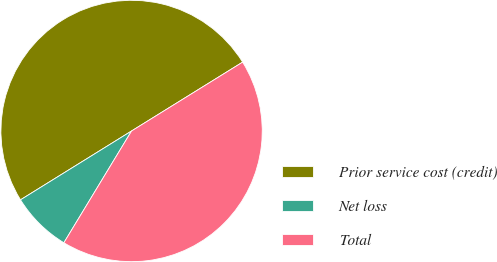<chart> <loc_0><loc_0><loc_500><loc_500><pie_chart><fcel>Prior service cost (credit)<fcel>Net loss<fcel>Total<nl><fcel>50.0%<fcel>7.5%<fcel>42.5%<nl></chart> 